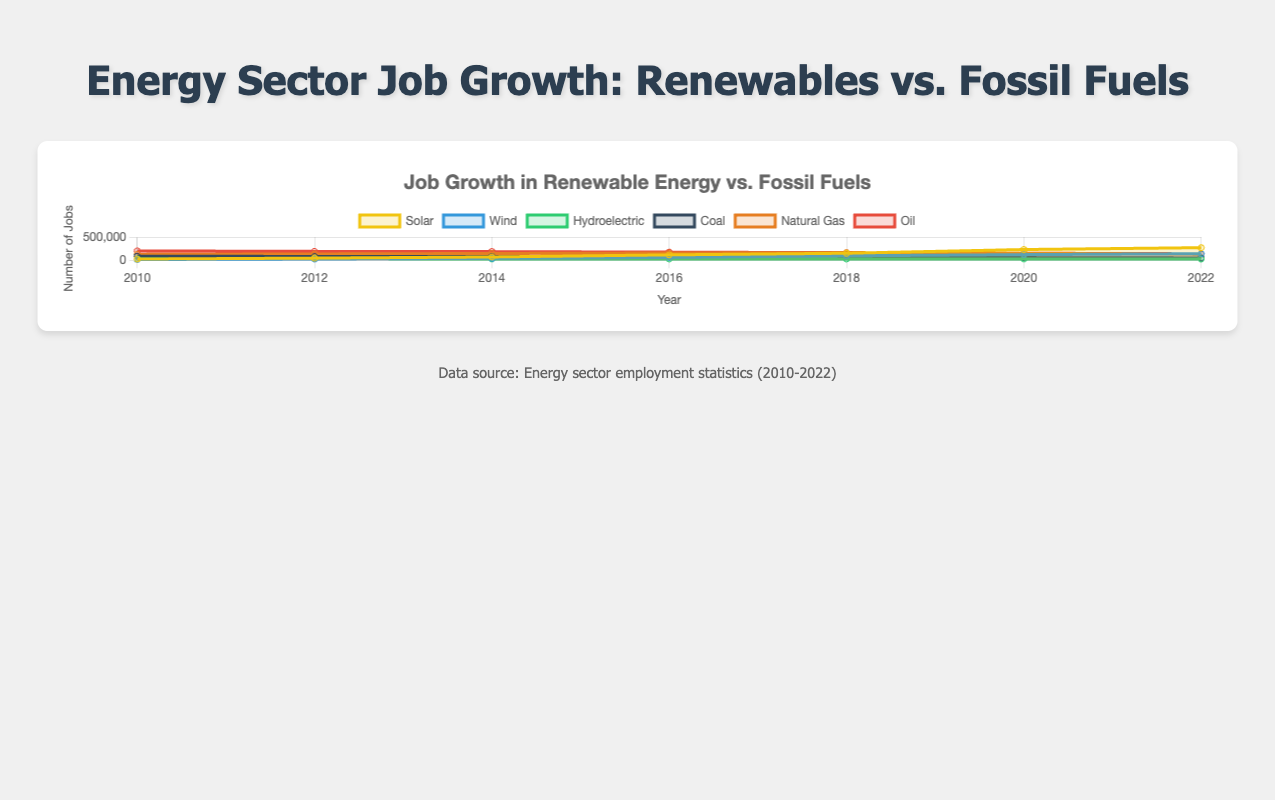What years are included in the dataset? The x-axis labels display the years, showing when data points are measured.
Answer: 2010, 2012, 2014, 2016, 2018, 2020, 2022 Which type of energy sector saw the most consistent job growth from 2010 to 2022? By observing how each line increases or decreases, Solar energy shows a consistent rise in job numbers over time.
Answer: Solar In 2022, which renewable energy source had the most jobs? By examining the data points on the y-axis for each renewable energy category in 2022, Solar energy had the highest job count.
Answer: Solar How many jobs did the coal sector lose from 2010 to 2022? Subtract the coal jobs in 2022 from 2010 (86000 - 49000).
Answer: 37000 Which energy sector had the least job growth from 2010 to 2022? Compare the difference in job counts for each sector between 2010 and 2022. Hydroelectric shows minimal change.
Answer: Hydroelectric Compare the job numbers for Solar and Oil in 2016. Which had more, and by how much? Look at the 2016 data points for both Solar (115000) and Oil (174000), then find the difference. (174000 - 115000).
Answer: Oil by 59000 Which fossil fuel energy source saw the steepest decline in job numbers from 2010 to 2022? Comparing the slopes of each fossil fuel line, Coal shows the steepest decline.
Answer: Coal What is the overall trend in job numbers for Natural Gas from 2010 to 2022? The Natural Gas line peaks around 2018 and then declines, indicating an initial rise followed by a fall.
Answer: Rise then fall Between 2010 and 2018, which renewable energy source experienced the largest increase in jobs? Calculate the difference between 2018 and 2010 for each renewable source. Solar increased from 25000 to 150000, the largest growth.
Answer: Solar Did any energy sector experience a job count decrease between 2020 and 2022? Analyze if any lines slope downward between 2020 and 2022. Natural Gas job numbers decreased from 148000 to 130000.
Answer: Natural Gas 